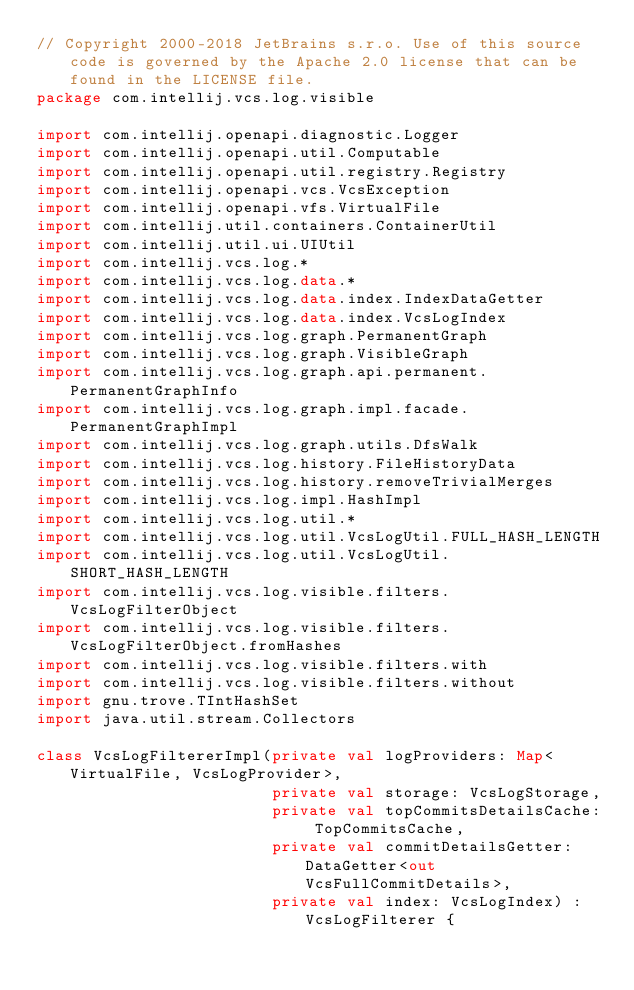Convert code to text. <code><loc_0><loc_0><loc_500><loc_500><_Kotlin_>// Copyright 2000-2018 JetBrains s.r.o. Use of this source code is governed by the Apache 2.0 license that can be found in the LICENSE file.
package com.intellij.vcs.log.visible

import com.intellij.openapi.diagnostic.Logger
import com.intellij.openapi.util.Computable
import com.intellij.openapi.util.registry.Registry
import com.intellij.openapi.vcs.VcsException
import com.intellij.openapi.vfs.VirtualFile
import com.intellij.util.containers.ContainerUtil
import com.intellij.util.ui.UIUtil
import com.intellij.vcs.log.*
import com.intellij.vcs.log.data.*
import com.intellij.vcs.log.data.index.IndexDataGetter
import com.intellij.vcs.log.data.index.VcsLogIndex
import com.intellij.vcs.log.graph.PermanentGraph
import com.intellij.vcs.log.graph.VisibleGraph
import com.intellij.vcs.log.graph.api.permanent.PermanentGraphInfo
import com.intellij.vcs.log.graph.impl.facade.PermanentGraphImpl
import com.intellij.vcs.log.graph.utils.DfsWalk
import com.intellij.vcs.log.history.FileHistoryData
import com.intellij.vcs.log.history.removeTrivialMerges
import com.intellij.vcs.log.impl.HashImpl
import com.intellij.vcs.log.util.*
import com.intellij.vcs.log.util.VcsLogUtil.FULL_HASH_LENGTH
import com.intellij.vcs.log.util.VcsLogUtil.SHORT_HASH_LENGTH
import com.intellij.vcs.log.visible.filters.VcsLogFilterObject
import com.intellij.vcs.log.visible.filters.VcsLogFilterObject.fromHashes
import com.intellij.vcs.log.visible.filters.with
import com.intellij.vcs.log.visible.filters.without
import gnu.trove.TIntHashSet
import java.util.stream.Collectors

class VcsLogFiltererImpl(private val logProviders: Map<VirtualFile, VcsLogProvider>,
                         private val storage: VcsLogStorage,
                         private val topCommitsDetailsCache: TopCommitsCache,
                         private val commitDetailsGetter: DataGetter<out VcsFullCommitDetails>,
                         private val index: VcsLogIndex) : VcsLogFilterer {
</code> 